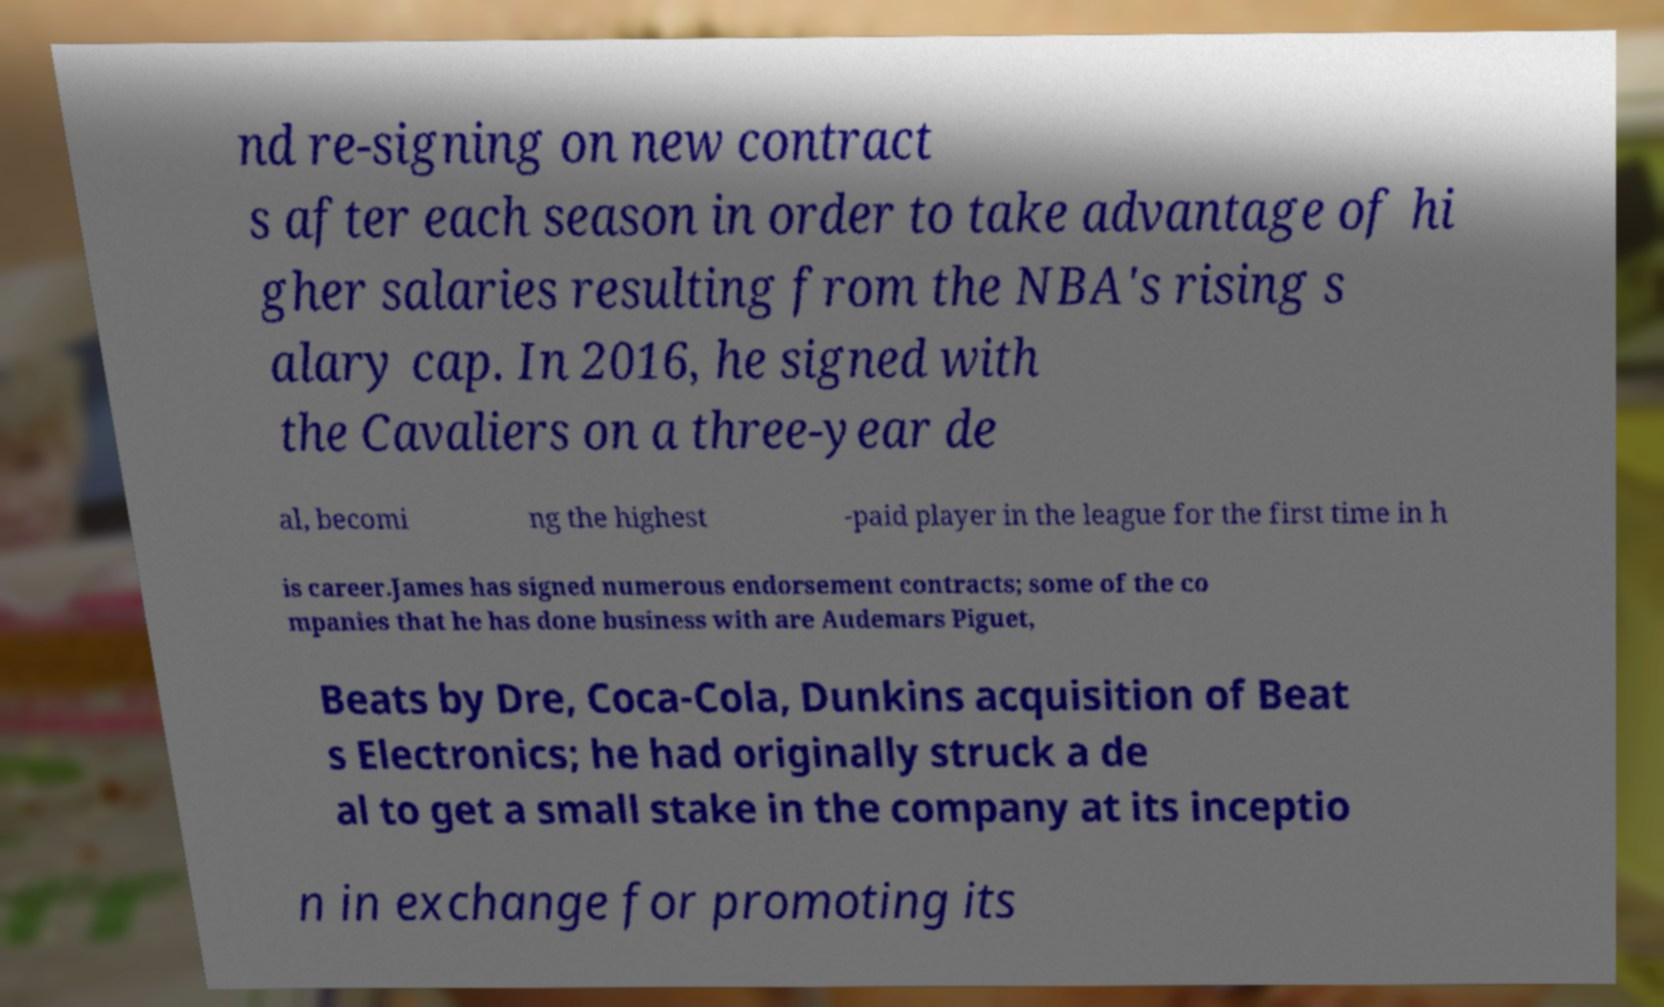Can you accurately transcribe the text from the provided image for me? nd re-signing on new contract s after each season in order to take advantage of hi gher salaries resulting from the NBA's rising s alary cap. In 2016, he signed with the Cavaliers on a three-year de al, becomi ng the highest -paid player in the league for the first time in h is career.James has signed numerous endorsement contracts; some of the co mpanies that he has done business with are Audemars Piguet, Beats by Dre, Coca-Cola, Dunkins acquisition of Beat s Electronics; he had originally struck a de al to get a small stake in the company at its inceptio n in exchange for promoting its 